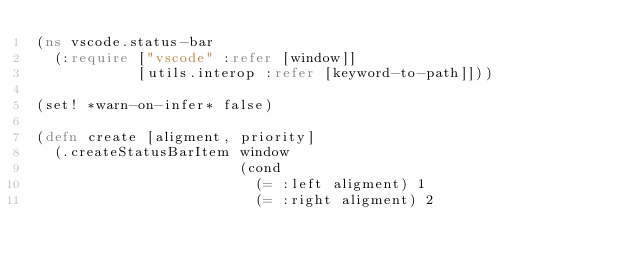<code> <loc_0><loc_0><loc_500><loc_500><_Clojure_>(ns vscode.status-bar
  (:require ["vscode" :refer [window]]
            [utils.interop :refer [keyword-to-path]]))

(set! *warn-on-infer* false)

(defn create [aligment, priority]
  (.createStatusBarItem window
                        (cond
                          (= :left aligment) 1
                          (= :right aligment) 2</code> 